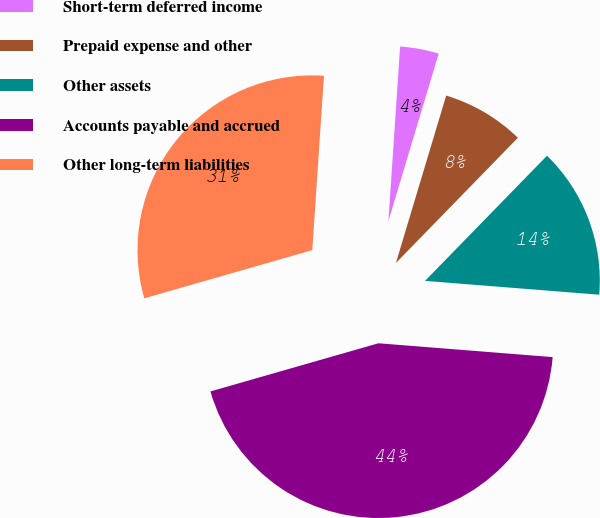Convert chart. <chart><loc_0><loc_0><loc_500><loc_500><pie_chart><fcel>Short-term deferred income<fcel>Prepaid expense and other<fcel>Other assets<fcel>Accounts payable and accrued<fcel>Other long-term liabilities<nl><fcel>3.58%<fcel>7.65%<fcel>13.97%<fcel>44.3%<fcel>30.51%<nl></chart> 